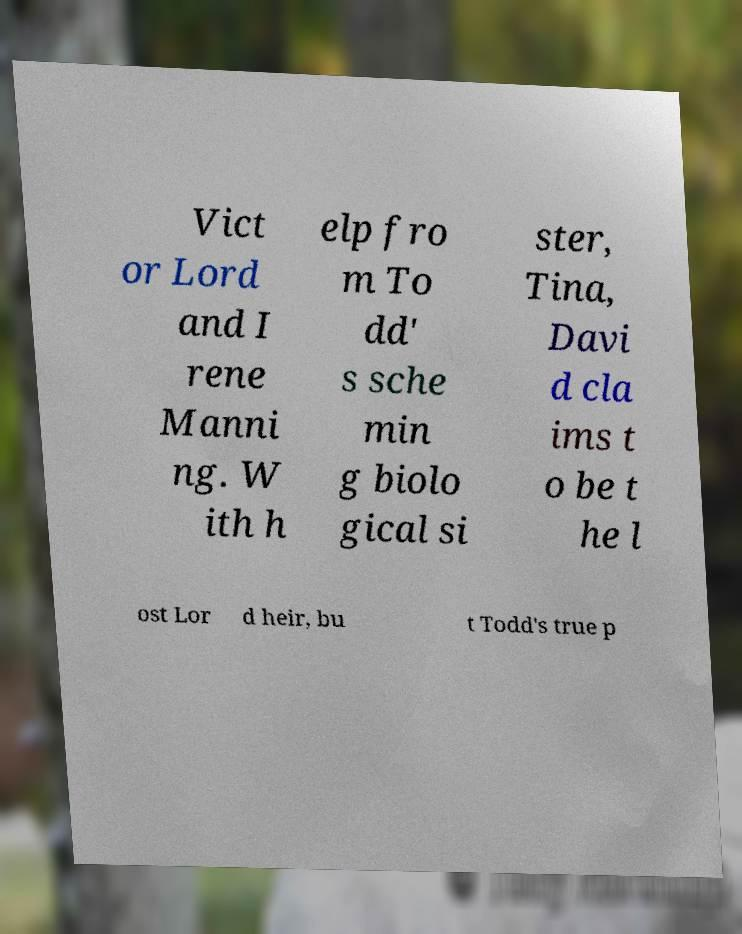For documentation purposes, I need the text within this image transcribed. Could you provide that? Vict or Lord and I rene Manni ng. W ith h elp fro m To dd' s sche min g biolo gical si ster, Tina, Davi d cla ims t o be t he l ost Lor d heir, bu t Todd's true p 